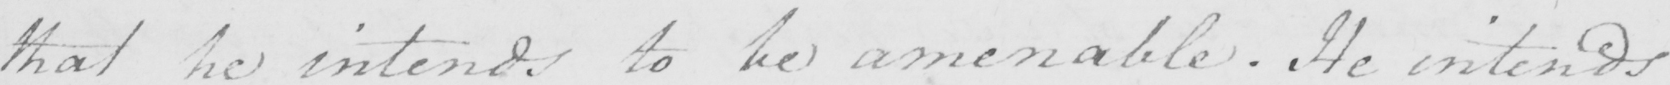Can you tell me what this handwritten text says? that he intends to be amenable . He intends 